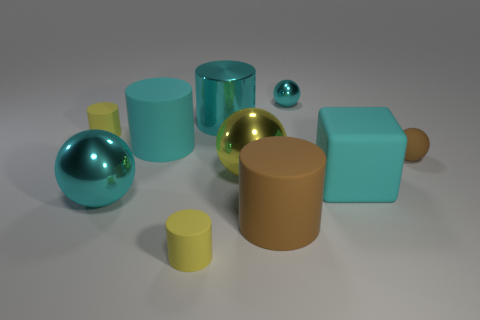Subtract 1 balls. How many balls are left? 3 Subtract all brown cylinders. How many cylinders are left? 4 Subtract all yellow cylinders. How many cylinders are left? 3 Subtract all blue cylinders. Subtract all green blocks. How many cylinders are left? 5 Subtract all blocks. How many objects are left? 9 Add 4 big rubber things. How many big rubber things exist? 7 Subtract 0 green cubes. How many objects are left? 10 Subtract all matte things. Subtract all large blue shiny things. How many objects are left? 4 Add 9 large cyan balls. How many large cyan balls are left? 10 